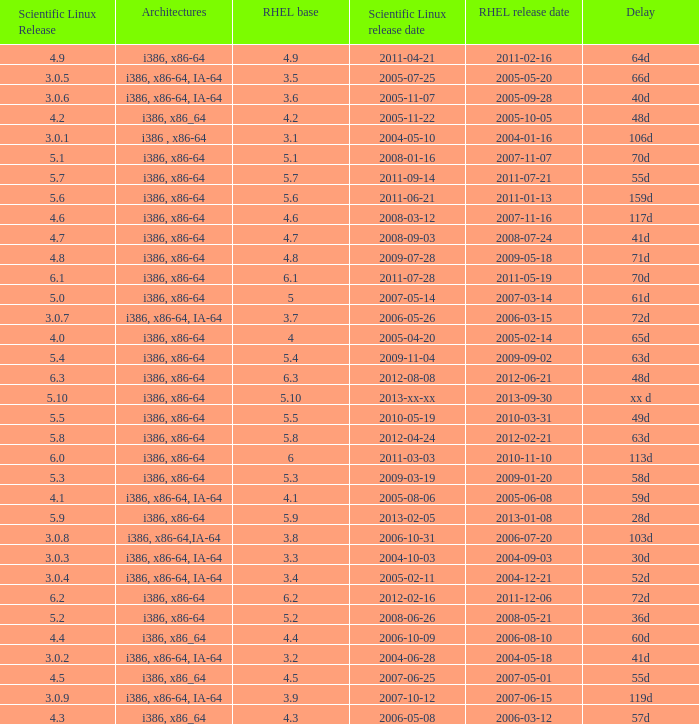What is the delay called when the release of scientific linux is 5.10? Xx d. 